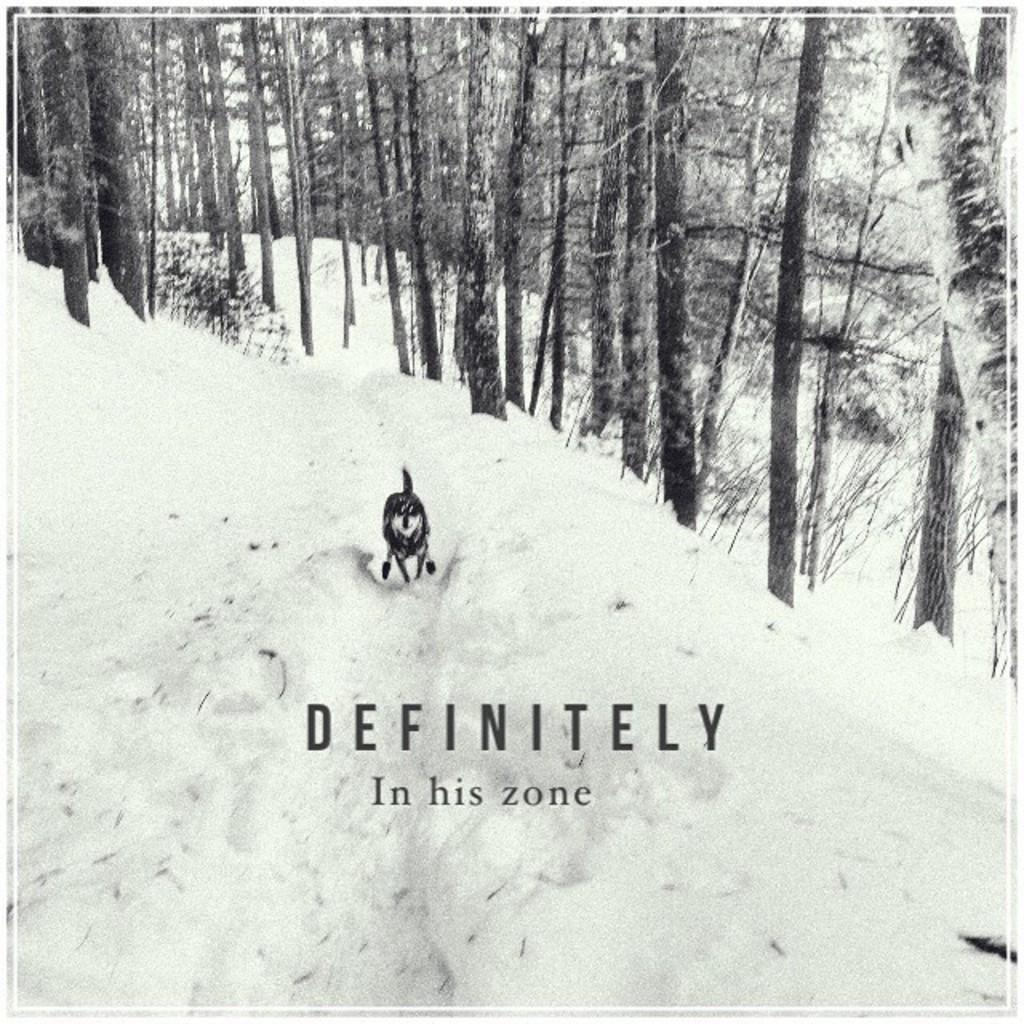What type of animal can be seen in the image? There is an animal in the image, but its specific type cannot be determined from the provided facts. What is the terrain on which the animal is standing? The animal is on snow in the image. What can be seen in the background of the image? There are trees in the background of the image. What discovery was made during the rainstorm in the image? There is no rainstorm present in the image, and therefore no discovery can be made during a rainstorm. 